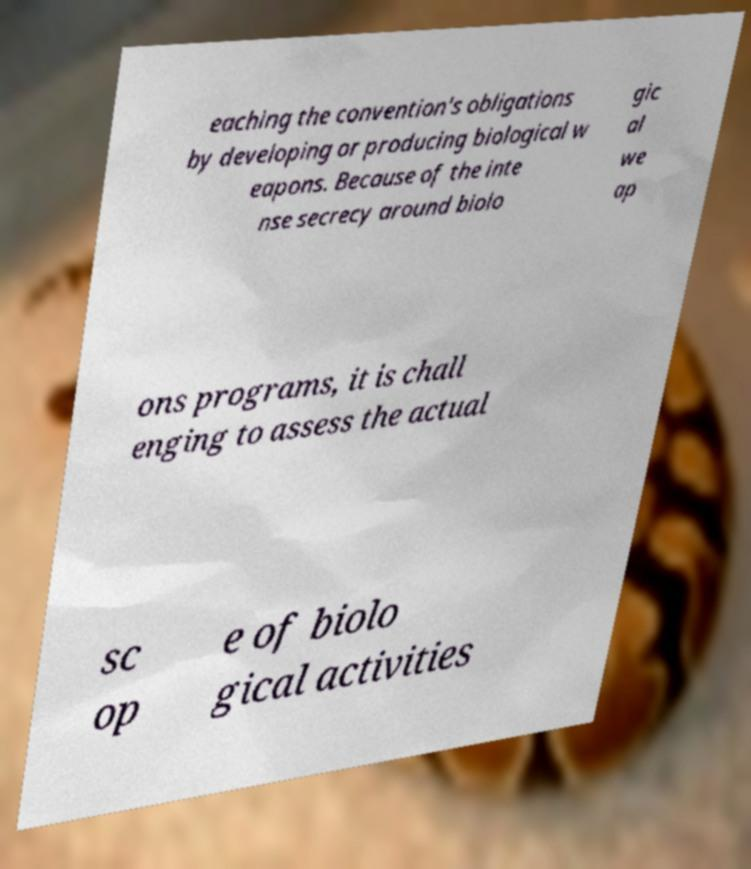There's text embedded in this image that I need extracted. Can you transcribe it verbatim? eaching the convention's obligations by developing or producing biological w eapons. Because of the inte nse secrecy around biolo gic al we ap ons programs, it is chall enging to assess the actual sc op e of biolo gical activities 